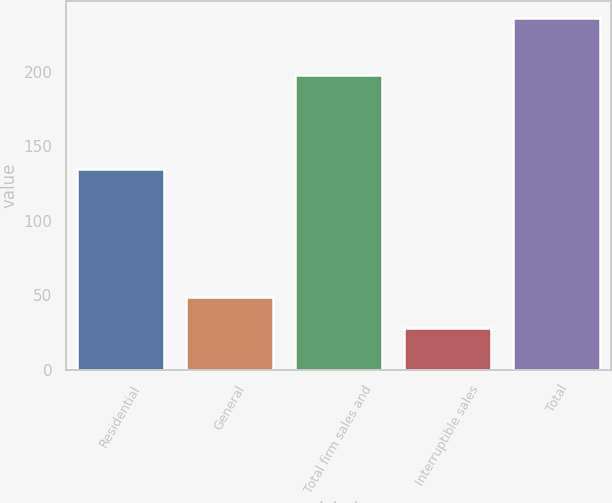<chart> <loc_0><loc_0><loc_500><loc_500><bar_chart><fcel>Residential<fcel>General<fcel>Total firm sales and<fcel>Interruptible sales<fcel>Total<nl><fcel>135<fcel>48.8<fcel>198<fcel>28<fcel>236<nl></chart> 